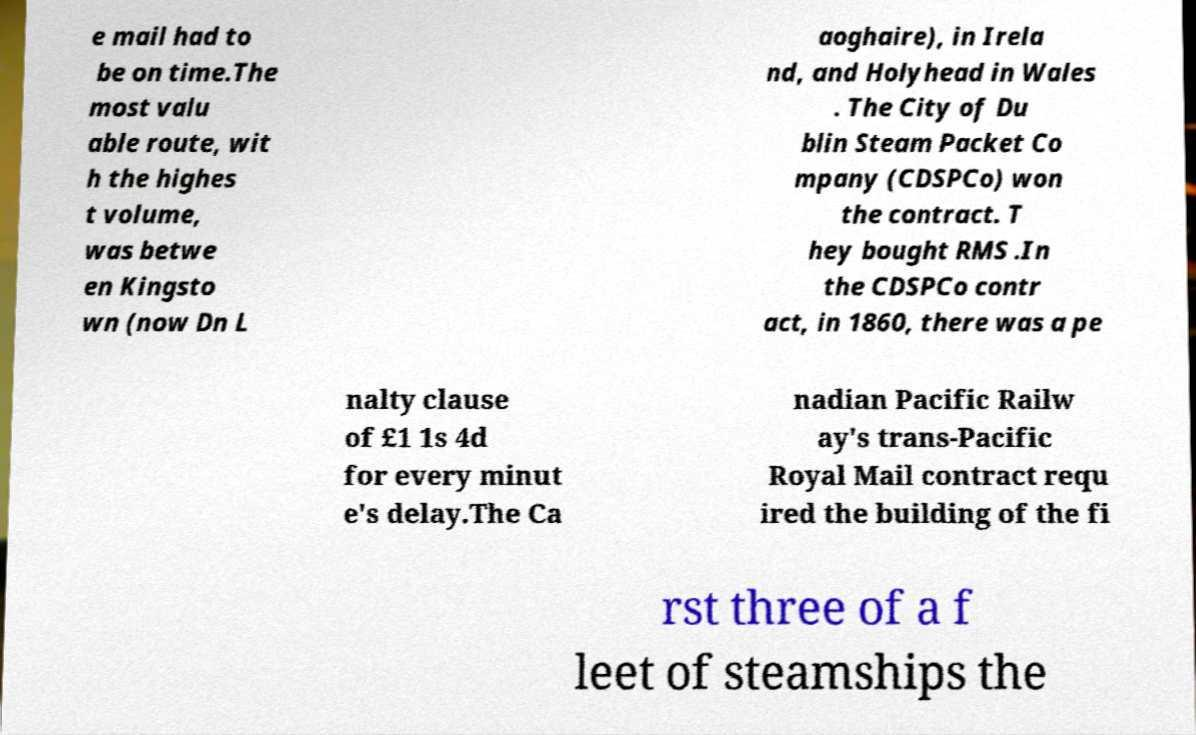Could you assist in decoding the text presented in this image and type it out clearly? e mail had to be on time.The most valu able route, wit h the highes t volume, was betwe en Kingsto wn (now Dn L aoghaire), in Irela nd, and Holyhead in Wales . The City of Du blin Steam Packet Co mpany (CDSPCo) won the contract. T hey bought RMS .In the CDSPCo contr act, in 1860, there was a pe nalty clause of £1 1s 4d for every minut e's delay.The Ca nadian Pacific Railw ay's trans-Pacific Royal Mail contract requ ired the building of the fi rst three of a f leet of steamships the 